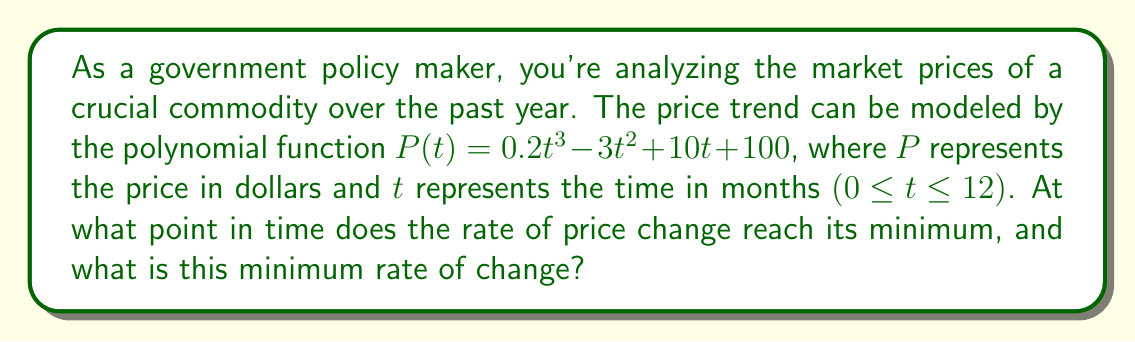Show me your answer to this math problem. To solve this problem, we need to follow these steps:

1) The rate of change of price is given by the first derivative of $P(t)$. Let's call this $P'(t)$:

   $$P'(t) = 0.6t^2 - 6t + 10$$

2) To find the minimum rate of change, we need to find where the derivative of $P'(t)$ equals zero. This is the second derivative of the original function, $P''(t)$:

   $$P''(t) = 1.2t - 6$$

3) Set $P''(t) = 0$ and solve for $t$:

   $$1.2t - 6 = 0$$
   $$1.2t = 6$$
   $$t = 5$$

4) This critical point at $t = 5$ could be a maximum or minimum. To confirm it's a minimum, we can check that $P'''(t) > 0$:

   $$P'''(t) = 1.2 > 0$$

   Since this is positive, $t = 5$ indeed gives a minimum.

5) To find the minimum rate of change, we substitute $t = 5$ into $P'(t)$:

   $$P'(5) = 0.6(5)^2 - 6(5) + 10$$
   $$= 0.6(25) - 30 + 10$$
   $$= 15 - 30 + 10$$
   $$= -5$$

Therefore, the rate of change reaches its minimum at $t = 5$ months, and the minimum rate of change is $-5$ dollars per month.
Answer: The rate of price change reaches its minimum at $t = 5$ months, and the minimum rate of change is $-5$ dollars per month. 